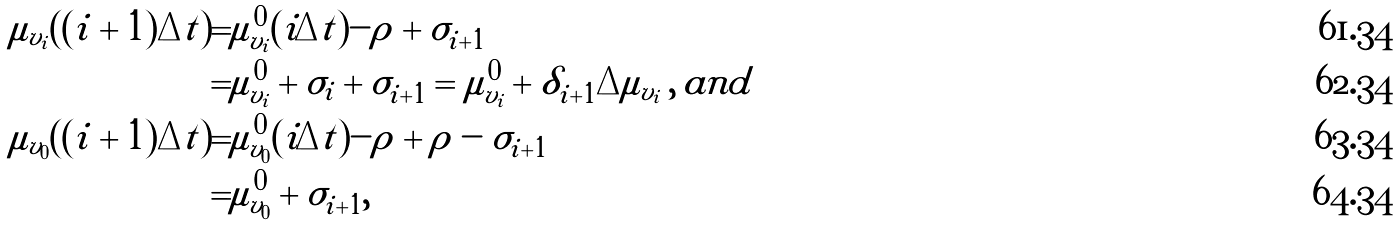<formula> <loc_0><loc_0><loc_500><loc_500>\mu _ { v _ { i } } ( ( { i + 1 } ) \Delta t ) = & \mu ^ { 0 } _ { v _ { i } } ( i \Delta t ) - \rho + \sigma _ { i + 1 } \\ = & \mu ^ { 0 } _ { v _ { i } } + \sigma _ { i } + \sigma _ { i + 1 } = \mu ^ { 0 } _ { v _ { i } } + \delta _ { i + 1 } \Delta \mu _ { v _ { i } } \, , \, a n d \\ \mu _ { v _ { 0 } } ( ( { i + 1 } ) \Delta t ) = & \mu ^ { 0 } _ { v _ { 0 } } ( i \Delta t ) - \rho + \rho - \sigma _ { i + 1 } \\ = & \mu ^ { 0 } _ { v _ { 0 } } + \sigma _ { i + 1 } ,</formula> 